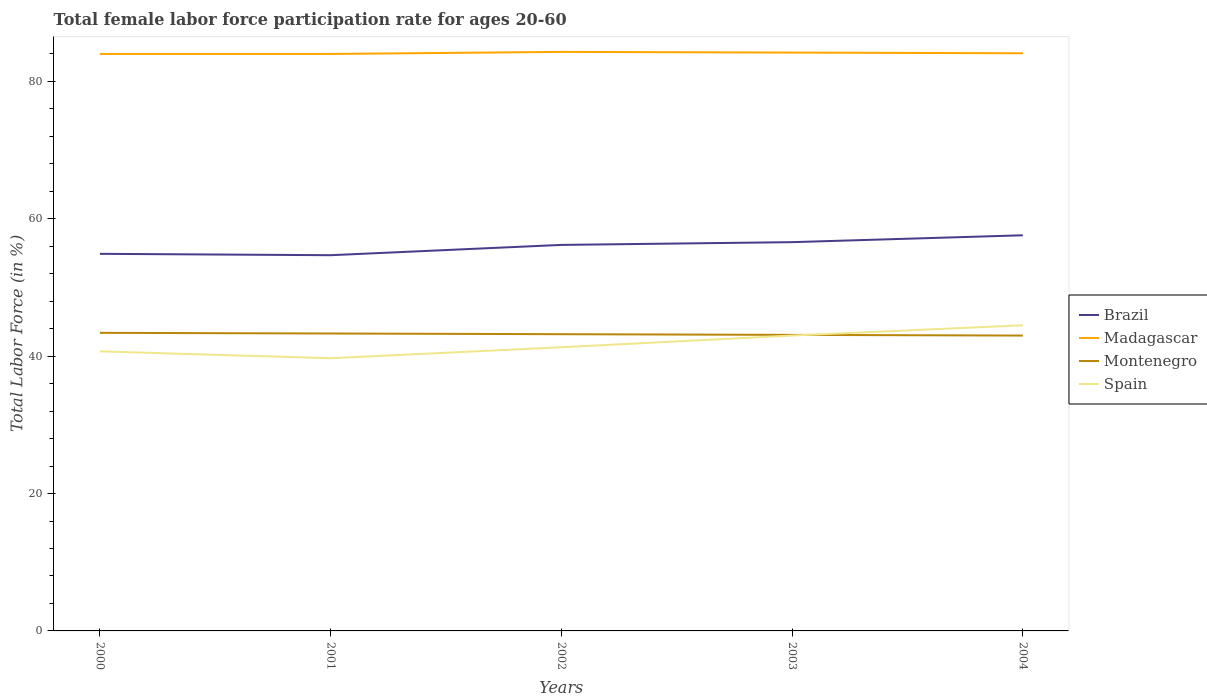Is the number of lines equal to the number of legend labels?
Your answer should be very brief. Yes. Across all years, what is the maximum female labor force participation rate in Spain?
Offer a very short reply. 39.7. What is the total female labor force participation rate in Madagascar in the graph?
Keep it short and to the point. -0.3. What is the difference between the highest and the second highest female labor force participation rate in Montenegro?
Offer a very short reply. 0.4. How many lines are there?
Offer a terse response. 4. How many years are there in the graph?
Give a very brief answer. 5. Are the values on the major ticks of Y-axis written in scientific E-notation?
Provide a short and direct response. No. Does the graph contain any zero values?
Your answer should be compact. No. How many legend labels are there?
Keep it short and to the point. 4. How are the legend labels stacked?
Keep it short and to the point. Vertical. What is the title of the graph?
Offer a terse response. Total female labor force participation rate for ages 20-60. What is the label or title of the Y-axis?
Offer a terse response. Total Labor Force (in %). What is the Total Labor Force (in %) of Brazil in 2000?
Your response must be concise. 54.9. What is the Total Labor Force (in %) in Montenegro in 2000?
Provide a succinct answer. 43.4. What is the Total Labor Force (in %) in Spain in 2000?
Give a very brief answer. 40.7. What is the Total Labor Force (in %) of Brazil in 2001?
Give a very brief answer. 54.7. What is the Total Labor Force (in %) of Madagascar in 2001?
Provide a short and direct response. 84. What is the Total Labor Force (in %) of Montenegro in 2001?
Make the answer very short. 43.3. What is the Total Labor Force (in %) in Spain in 2001?
Offer a terse response. 39.7. What is the Total Labor Force (in %) in Brazil in 2002?
Make the answer very short. 56.2. What is the Total Labor Force (in %) in Madagascar in 2002?
Make the answer very short. 84.3. What is the Total Labor Force (in %) in Montenegro in 2002?
Offer a terse response. 43.2. What is the Total Labor Force (in %) of Spain in 2002?
Your answer should be compact. 41.3. What is the Total Labor Force (in %) in Brazil in 2003?
Your answer should be very brief. 56.6. What is the Total Labor Force (in %) in Madagascar in 2003?
Make the answer very short. 84.2. What is the Total Labor Force (in %) in Montenegro in 2003?
Offer a very short reply. 43.1. What is the Total Labor Force (in %) of Spain in 2003?
Your response must be concise. 43. What is the Total Labor Force (in %) in Brazil in 2004?
Ensure brevity in your answer.  57.6. What is the Total Labor Force (in %) of Madagascar in 2004?
Make the answer very short. 84.1. What is the Total Labor Force (in %) in Montenegro in 2004?
Give a very brief answer. 43. What is the Total Labor Force (in %) of Spain in 2004?
Offer a very short reply. 44.5. Across all years, what is the maximum Total Labor Force (in %) of Brazil?
Offer a very short reply. 57.6. Across all years, what is the maximum Total Labor Force (in %) of Madagascar?
Provide a succinct answer. 84.3. Across all years, what is the maximum Total Labor Force (in %) in Montenegro?
Offer a very short reply. 43.4. Across all years, what is the maximum Total Labor Force (in %) of Spain?
Keep it short and to the point. 44.5. Across all years, what is the minimum Total Labor Force (in %) of Brazil?
Your response must be concise. 54.7. Across all years, what is the minimum Total Labor Force (in %) of Madagascar?
Your response must be concise. 84. Across all years, what is the minimum Total Labor Force (in %) of Montenegro?
Offer a terse response. 43. Across all years, what is the minimum Total Labor Force (in %) of Spain?
Provide a succinct answer. 39.7. What is the total Total Labor Force (in %) in Brazil in the graph?
Your response must be concise. 280. What is the total Total Labor Force (in %) in Madagascar in the graph?
Your answer should be compact. 420.6. What is the total Total Labor Force (in %) in Montenegro in the graph?
Keep it short and to the point. 216. What is the total Total Labor Force (in %) in Spain in the graph?
Give a very brief answer. 209.2. What is the difference between the Total Labor Force (in %) in Spain in 2000 and that in 2001?
Provide a succinct answer. 1. What is the difference between the Total Labor Force (in %) of Madagascar in 2000 and that in 2002?
Ensure brevity in your answer.  -0.3. What is the difference between the Total Labor Force (in %) of Montenegro in 2000 and that in 2002?
Give a very brief answer. 0.2. What is the difference between the Total Labor Force (in %) of Spain in 2000 and that in 2002?
Provide a succinct answer. -0.6. What is the difference between the Total Labor Force (in %) in Brazil in 2000 and that in 2003?
Your response must be concise. -1.7. What is the difference between the Total Labor Force (in %) in Madagascar in 2000 and that in 2003?
Offer a very short reply. -0.2. What is the difference between the Total Labor Force (in %) in Montenegro in 2000 and that in 2003?
Keep it short and to the point. 0.3. What is the difference between the Total Labor Force (in %) in Spain in 2000 and that in 2004?
Make the answer very short. -3.8. What is the difference between the Total Labor Force (in %) in Brazil in 2001 and that in 2003?
Provide a succinct answer. -1.9. What is the difference between the Total Labor Force (in %) in Madagascar in 2001 and that in 2003?
Your answer should be compact. -0.2. What is the difference between the Total Labor Force (in %) of Montenegro in 2001 and that in 2003?
Your response must be concise. 0.2. What is the difference between the Total Labor Force (in %) in Spain in 2001 and that in 2003?
Provide a short and direct response. -3.3. What is the difference between the Total Labor Force (in %) of Madagascar in 2001 and that in 2004?
Make the answer very short. -0.1. What is the difference between the Total Labor Force (in %) of Brazil in 2002 and that in 2003?
Keep it short and to the point. -0.4. What is the difference between the Total Labor Force (in %) in Montenegro in 2002 and that in 2003?
Offer a very short reply. 0.1. What is the difference between the Total Labor Force (in %) of Brazil in 2002 and that in 2004?
Your answer should be very brief. -1.4. What is the difference between the Total Labor Force (in %) in Spain in 2002 and that in 2004?
Offer a very short reply. -3.2. What is the difference between the Total Labor Force (in %) in Madagascar in 2003 and that in 2004?
Keep it short and to the point. 0.1. What is the difference between the Total Labor Force (in %) in Brazil in 2000 and the Total Labor Force (in %) in Madagascar in 2001?
Your answer should be very brief. -29.1. What is the difference between the Total Labor Force (in %) in Brazil in 2000 and the Total Labor Force (in %) in Montenegro in 2001?
Offer a very short reply. 11.6. What is the difference between the Total Labor Force (in %) of Brazil in 2000 and the Total Labor Force (in %) of Spain in 2001?
Offer a very short reply. 15.2. What is the difference between the Total Labor Force (in %) in Madagascar in 2000 and the Total Labor Force (in %) in Montenegro in 2001?
Keep it short and to the point. 40.7. What is the difference between the Total Labor Force (in %) in Madagascar in 2000 and the Total Labor Force (in %) in Spain in 2001?
Give a very brief answer. 44.3. What is the difference between the Total Labor Force (in %) of Brazil in 2000 and the Total Labor Force (in %) of Madagascar in 2002?
Ensure brevity in your answer.  -29.4. What is the difference between the Total Labor Force (in %) of Brazil in 2000 and the Total Labor Force (in %) of Montenegro in 2002?
Your response must be concise. 11.7. What is the difference between the Total Labor Force (in %) in Madagascar in 2000 and the Total Labor Force (in %) in Montenegro in 2002?
Your answer should be compact. 40.8. What is the difference between the Total Labor Force (in %) of Madagascar in 2000 and the Total Labor Force (in %) of Spain in 2002?
Provide a short and direct response. 42.7. What is the difference between the Total Labor Force (in %) in Montenegro in 2000 and the Total Labor Force (in %) in Spain in 2002?
Make the answer very short. 2.1. What is the difference between the Total Labor Force (in %) of Brazil in 2000 and the Total Labor Force (in %) of Madagascar in 2003?
Your response must be concise. -29.3. What is the difference between the Total Labor Force (in %) of Brazil in 2000 and the Total Labor Force (in %) of Spain in 2003?
Ensure brevity in your answer.  11.9. What is the difference between the Total Labor Force (in %) of Madagascar in 2000 and the Total Labor Force (in %) of Montenegro in 2003?
Give a very brief answer. 40.9. What is the difference between the Total Labor Force (in %) of Madagascar in 2000 and the Total Labor Force (in %) of Spain in 2003?
Offer a very short reply. 41. What is the difference between the Total Labor Force (in %) of Montenegro in 2000 and the Total Labor Force (in %) of Spain in 2003?
Make the answer very short. 0.4. What is the difference between the Total Labor Force (in %) of Brazil in 2000 and the Total Labor Force (in %) of Madagascar in 2004?
Give a very brief answer. -29.2. What is the difference between the Total Labor Force (in %) of Brazil in 2000 and the Total Labor Force (in %) of Montenegro in 2004?
Provide a short and direct response. 11.9. What is the difference between the Total Labor Force (in %) in Brazil in 2000 and the Total Labor Force (in %) in Spain in 2004?
Provide a succinct answer. 10.4. What is the difference between the Total Labor Force (in %) in Madagascar in 2000 and the Total Labor Force (in %) in Montenegro in 2004?
Your response must be concise. 41. What is the difference between the Total Labor Force (in %) in Madagascar in 2000 and the Total Labor Force (in %) in Spain in 2004?
Provide a short and direct response. 39.5. What is the difference between the Total Labor Force (in %) in Brazil in 2001 and the Total Labor Force (in %) in Madagascar in 2002?
Offer a terse response. -29.6. What is the difference between the Total Labor Force (in %) of Brazil in 2001 and the Total Labor Force (in %) of Montenegro in 2002?
Your answer should be very brief. 11.5. What is the difference between the Total Labor Force (in %) of Madagascar in 2001 and the Total Labor Force (in %) of Montenegro in 2002?
Offer a very short reply. 40.8. What is the difference between the Total Labor Force (in %) of Madagascar in 2001 and the Total Labor Force (in %) of Spain in 2002?
Ensure brevity in your answer.  42.7. What is the difference between the Total Labor Force (in %) of Brazil in 2001 and the Total Labor Force (in %) of Madagascar in 2003?
Offer a very short reply. -29.5. What is the difference between the Total Labor Force (in %) in Brazil in 2001 and the Total Labor Force (in %) in Montenegro in 2003?
Offer a very short reply. 11.6. What is the difference between the Total Labor Force (in %) of Brazil in 2001 and the Total Labor Force (in %) of Spain in 2003?
Make the answer very short. 11.7. What is the difference between the Total Labor Force (in %) of Madagascar in 2001 and the Total Labor Force (in %) of Montenegro in 2003?
Give a very brief answer. 40.9. What is the difference between the Total Labor Force (in %) in Madagascar in 2001 and the Total Labor Force (in %) in Spain in 2003?
Your answer should be compact. 41. What is the difference between the Total Labor Force (in %) in Brazil in 2001 and the Total Labor Force (in %) in Madagascar in 2004?
Keep it short and to the point. -29.4. What is the difference between the Total Labor Force (in %) of Madagascar in 2001 and the Total Labor Force (in %) of Montenegro in 2004?
Your response must be concise. 41. What is the difference between the Total Labor Force (in %) of Madagascar in 2001 and the Total Labor Force (in %) of Spain in 2004?
Offer a terse response. 39.5. What is the difference between the Total Labor Force (in %) in Brazil in 2002 and the Total Labor Force (in %) in Madagascar in 2003?
Provide a succinct answer. -28. What is the difference between the Total Labor Force (in %) in Brazil in 2002 and the Total Labor Force (in %) in Montenegro in 2003?
Provide a succinct answer. 13.1. What is the difference between the Total Labor Force (in %) of Brazil in 2002 and the Total Labor Force (in %) of Spain in 2003?
Your answer should be compact. 13.2. What is the difference between the Total Labor Force (in %) in Madagascar in 2002 and the Total Labor Force (in %) in Montenegro in 2003?
Offer a terse response. 41.2. What is the difference between the Total Labor Force (in %) in Madagascar in 2002 and the Total Labor Force (in %) in Spain in 2003?
Your answer should be very brief. 41.3. What is the difference between the Total Labor Force (in %) of Brazil in 2002 and the Total Labor Force (in %) of Madagascar in 2004?
Provide a succinct answer. -27.9. What is the difference between the Total Labor Force (in %) of Brazil in 2002 and the Total Labor Force (in %) of Montenegro in 2004?
Ensure brevity in your answer.  13.2. What is the difference between the Total Labor Force (in %) of Madagascar in 2002 and the Total Labor Force (in %) of Montenegro in 2004?
Your response must be concise. 41.3. What is the difference between the Total Labor Force (in %) of Madagascar in 2002 and the Total Labor Force (in %) of Spain in 2004?
Offer a very short reply. 39.8. What is the difference between the Total Labor Force (in %) of Montenegro in 2002 and the Total Labor Force (in %) of Spain in 2004?
Keep it short and to the point. -1.3. What is the difference between the Total Labor Force (in %) in Brazil in 2003 and the Total Labor Force (in %) in Madagascar in 2004?
Give a very brief answer. -27.5. What is the difference between the Total Labor Force (in %) of Brazil in 2003 and the Total Labor Force (in %) of Montenegro in 2004?
Your response must be concise. 13.6. What is the difference between the Total Labor Force (in %) in Madagascar in 2003 and the Total Labor Force (in %) in Montenegro in 2004?
Ensure brevity in your answer.  41.2. What is the difference between the Total Labor Force (in %) of Madagascar in 2003 and the Total Labor Force (in %) of Spain in 2004?
Your answer should be very brief. 39.7. What is the average Total Labor Force (in %) in Madagascar per year?
Ensure brevity in your answer.  84.12. What is the average Total Labor Force (in %) of Montenegro per year?
Provide a succinct answer. 43.2. What is the average Total Labor Force (in %) in Spain per year?
Ensure brevity in your answer.  41.84. In the year 2000, what is the difference between the Total Labor Force (in %) in Brazil and Total Labor Force (in %) in Madagascar?
Your response must be concise. -29.1. In the year 2000, what is the difference between the Total Labor Force (in %) in Brazil and Total Labor Force (in %) in Montenegro?
Offer a very short reply. 11.5. In the year 2000, what is the difference between the Total Labor Force (in %) in Madagascar and Total Labor Force (in %) in Montenegro?
Provide a succinct answer. 40.6. In the year 2000, what is the difference between the Total Labor Force (in %) in Madagascar and Total Labor Force (in %) in Spain?
Offer a terse response. 43.3. In the year 2000, what is the difference between the Total Labor Force (in %) of Montenegro and Total Labor Force (in %) of Spain?
Provide a succinct answer. 2.7. In the year 2001, what is the difference between the Total Labor Force (in %) in Brazil and Total Labor Force (in %) in Madagascar?
Keep it short and to the point. -29.3. In the year 2001, what is the difference between the Total Labor Force (in %) of Brazil and Total Labor Force (in %) of Montenegro?
Offer a terse response. 11.4. In the year 2001, what is the difference between the Total Labor Force (in %) of Brazil and Total Labor Force (in %) of Spain?
Offer a very short reply. 15. In the year 2001, what is the difference between the Total Labor Force (in %) of Madagascar and Total Labor Force (in %) of Montenegro?
Your answer should be very brief. 40.7. In the year 2001, what is the difference between the Total Labor Force (in %) of Madagascar and Total Labor Force (in %) of Spain?
Your response must be concise. 44.3. In the year 2002, what is the difference between the Total Labor Force (in %) of Brazil and Total Labor Force (in %) of Madagascar?
Give a very brief answer. -28.1. In the year 2002, what is the difference between the Total Labor Force (in %) in Brazil and Total Labor Force (in %) in Montenegro?
Provide a short and direct response. 13. In the year 2002, what is the difference between the Total Labor Force (in %) in Brazil and Total Labor Force (in %) in Spain?
Provide a succinct answer. 14.9. In the year 2002, what is the difference between the Total Labor Force (in %) of Madagascar and Total Labor Force (in %) of Montenegro?
Ensure brevity in your answer.  41.1. In the year 2002, what is the difference between the Total Labor Force (in %) in Montenegro and Total Labor Force (in %) in Spain?
Offer a very short reply. 1.9. In the year 2003, what is the difference between the Total Labor Force (in %) of Brazil and Total Labor Force (in %) of Madagascar?
Give a very brief answer. -27.6. In the year 2003, what is the difference between the Total Labor Force (in %) of Madagascar and Total Labor Force (in %) of Montenegro?
Make the answer very short. 41.1. In the year 2003, what is the difference between the Total Labor Force (in %) in Madagascar and Total Labor Force (in %) in Spain?
Provide a short and direct response. 41.2. In the year 2004, what is the difference between the Total Labor Force (in %) in Brazil and Total Labor Force (in %) in Madagascar?
Make the answer very short. -26.5. In the year 2004, what is the difference between the Total Labor Force (in %) of Madagascar and Total Labor Force (in %) of Montenegro?
Provide a short and direct response. 41.1. In the year 2004, what is the difference between the Total Labor Force (in %) in Madagascar and Total Labor Force (in %) in Spain?
Keep it short and to the point. 39.6. What is the ratio of the Total Labor Force (in %) in Brazil in 2000 to that in 2001?
Provide a short and direct response. 1. What is the ratio of the Total Labor Force (in %) in Spain in 2000 to that in 2001?
Give a very brief answer. 1.03. What is the ratio of the Total Labor Force (in %) in Brazil in 2000 to that in 2002?
Offer a very short reply. 0.98. What is the ratio of the Total Labor Force (in %) in Madagascar in 2000 to that in 2002?
Provide a succinct answer. 1. What is the ratio of the Total Labor Force (in %) of Spain in 2000 to that in 2002?
Make the answer very short. 0.99. What is the ratio of the Total Labor Force (in %) of Brazil in 2000 to that in 2003?
Make the answer very short. 0.97. What is the ratio of the Total Labor Force (in %) of Montenegro in 2000 to that in 2003?
Make the answer very short. 1.01. What is the ratio of the Total Labor Force (in %) of Spain in 2000 to that in 2003?
Your response must be concise. 0.95. What is the ratio of the Total Labor Force (in %) of Brazil in 2000 to that in 2004?
Make the answer very short. 0.95. What is the ratio of the Total Labor Force (in %) in Madagascar in 2000 to that in 2004?
Provide a succinct answer. 1. What is the ratio of the Total Labor Force (in %) in Montenegro in 2000 to that in 2004?
Your response must be concise. 1.01. What is the ratio of the Total Labor Force (in %) in Spain in 2000 to that in 2004?
Keep it short and to the point. 0.91. What is the ratio of the Total Labor Force (in %) in Brazil in 2001 to that in 2002?
Give a very brief answer. 0.97. What is the ratio of the Total Labor Force (in %) in Spain in 2001 to that in 2002?
Your answer should be compact. 0.96. What is the ratio of the Total Labor Force (in %) of Brazil in 2001 to that in 2003?
Keep it short and to the point. 0.97. What is the ratio of the Total Labor Force (in %) of Montenegro in 2001 to that in 2003?
Your response must be concise. 1. What is the ratio of the Total Labor Force (in %) in Spain in 2001 to that in 2003?
Ensure brevity in your answer.  0.92. What is the ratio of the Total Labor Force (in %) of Brazil in 2001 to that in 2004?
Offer a terse response. 0.95. What is the ratio of the Total Labor Force (in %) of Montenegro in 2001 to that in 2004?
Offer a terse response. 1.01. What is the ratio of the Total Labor Force (in %) of Spain in 2001 to that in 2004?
Ensure brevity in your answer.  0.89. What is the ratio of the Total Labor Force (in %) of Montenegro in 2002 to that in 2003?
Give a very brief answer. 1. What is the ratio of the Total Labor Force (in %) in Spain in 2002 to that in 2003?
Ensure brevity in your answer.  0.96. What is the ratio of the Total Labor Force (in %) in Brazil in 2002 to that in 2004?
Ensure brevity in your answer.  0.98. What is the ratio of the Total Labor Force (in %) in Spain in 2002 to that in 2004?
Your answer should be very brief. 0.93. What is the ratio of the Total Labor Force (in %) in Brazil in 2003 to that in 2004?
Give a very brief answer. 0.98. What is the ratio of the Total Labor Force (in %) of Spain in 2003 to that in 2004?
Provide a succinct answer. 0.97. What is the difference between the highest and the second highest Total Labor Force (in %) of Montenegro?
Your answer should be compact. 0.1. What is the difference between the highest and the lowest Total Labor Force (in %) in Madagascar?
Make the answer very short. 0.3. 